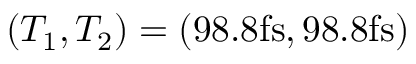<formula> <loc_0><loc_0><loc_500><loc_500>( T _ { 1 } , T _ { 2 } ) = ( 9 8 . 8 f s , 9 8 . 8 f s )</formula> 